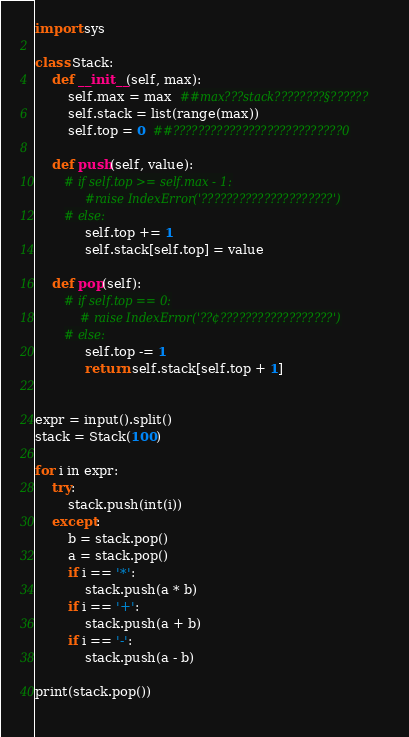Convert code to text. <code><loc_0><loc_0><loc_500><loc_500><_Python_>import sys

class Stack:
    def __init__(self, max):
        self.max = max  ##max???stack????????§??????
        self.stack = list(range(max)) 
        self.top = 0  ##???????????????????????????0

    def push(self, value):
       # if self.top >= self.max - 1:
            #raise IndexError('?????????????????????')
       # else:
            self.top += 1
            self.stack[self.top] = value

    def pop(self):
       # if self.top == 0:
           # raise IndexError('??¢??????????????????')
       # else:
            self.top -= 1
            return self.stack[self.top + 1]


expr = input().split()
stack = Stack(100)

for i in expr:
    try:
        stack.push(int(i))
    except:
        b = stack.pop()
        a = stack.pop()
        if i == '*':
            stack.push(a * b)
        if i == '+':
            stack.push(a + b)
        if i == '-':
            stack.push(a - b)

print(stack.pop())
                </code> 